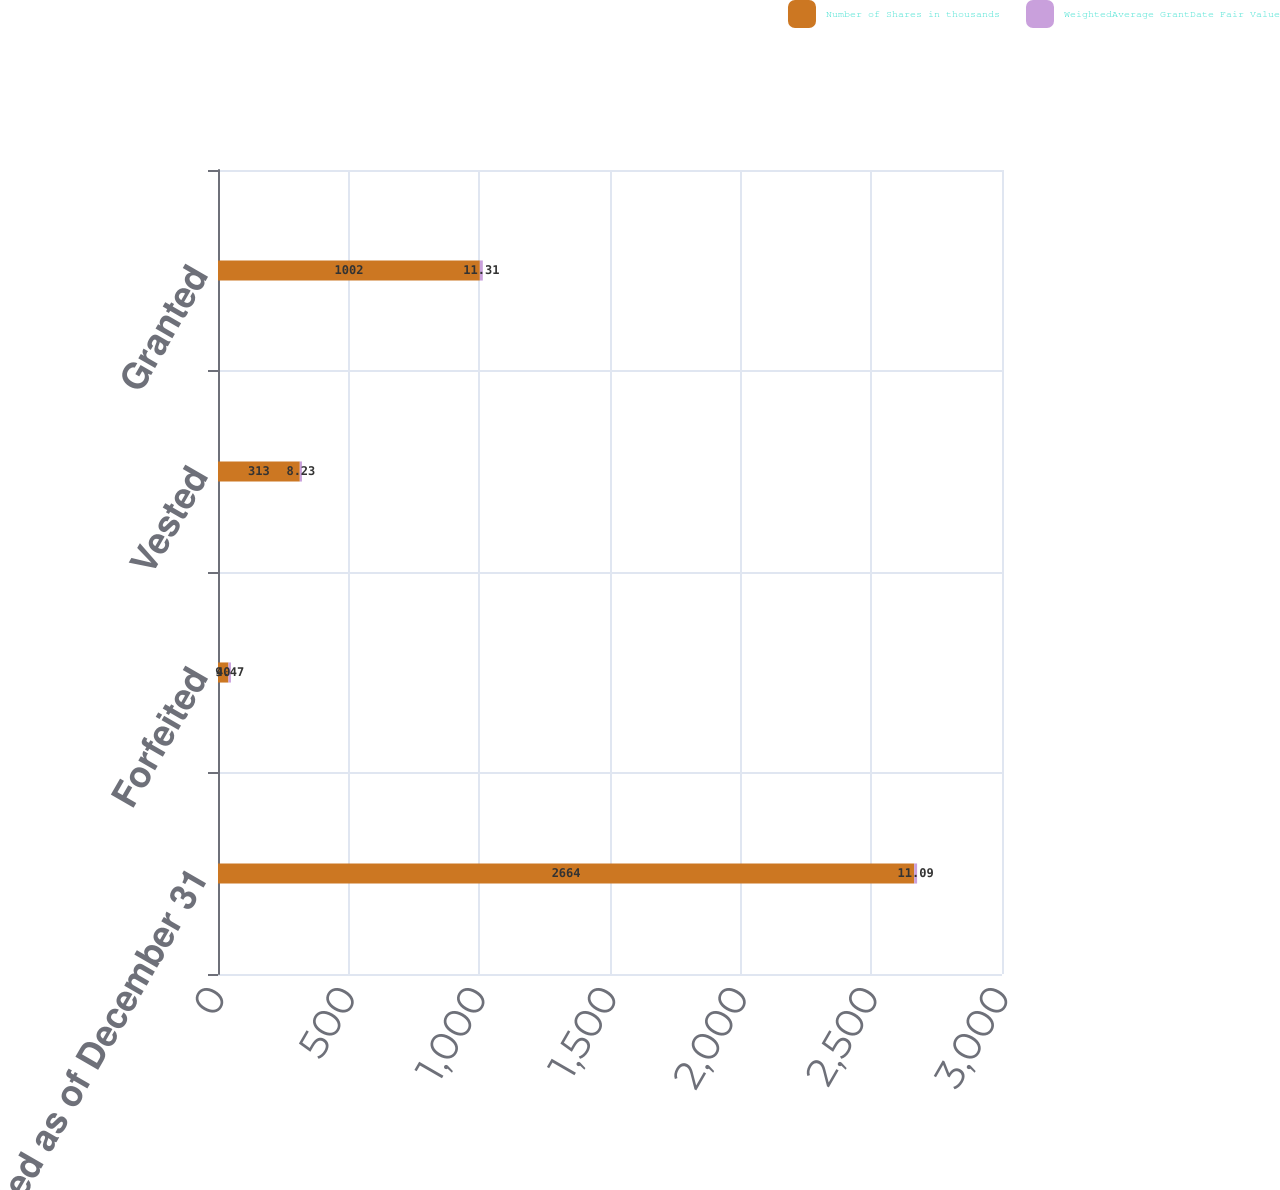<chart> <loc_0><loc_0><loc_500><loc_500><stacked_bar_chart><ecel><fcel>Unvested as of December 31<fcel>Forfeited<fcel>Vested<fcel>Granted<nl><fcel>Number of Shares in thousands<fcel>2664<fcel>40<fcel>313<fcel>1002<nl><fcel>WeightedAverage GrantDate Fair Value<fcel>11.09<fcel>9.47<fcel>8.23<fcel>11.31<nl></chart> 